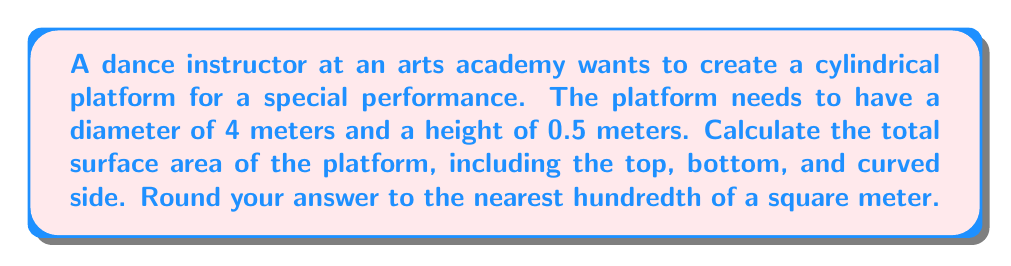Help me with this question. To solve this problem, we need to calculate the surface area of a cylinder. The surface area of a cylinder consists of three parts: the top circular face, the bottom circular face, and the curved lateral surface.

Let's break it down step by step:

1. Calculate the radius of the circular base:
   Given diameter = 4 meters
   $r = \frac{diameter}{2} = \frac{4}{2} = 2$ meters

2. Calculate the area of one circular face (top or bottom):
   $A_{circle} = \pi r^2 = \pi (2)^2 = 4\pi$ square meters

3. Calculate the area of both circular faces:
   $A_{circles} = 2 \times 4\pi = 8\pi$ square meters

4. Calculate the lateral surface area (curved side):
   Lateral surface area = circumference of base × height
   $A_{lateral} = 2\pi r \times h = 2\pi (2) \times 0.5 = 2\pi$ square meters

5. Calculate the total surface area:
   $A_{total} = A_{circles} + A_{lateral} = 8\pi + 2\pi = 10\pi$ square meters

6. Convert to numerical value and round to the nearest hundredth:
   $A_{total} = 10\pi \approx 31.42$ square meters

[asy]
import geometry;

size(200);
real r = 2;
real h = 0.5;

path base = circle((0,0),r);
path top = circle((0,h),r);

draw(base);
draw(top);
draw((r,0)--(r,h));
draw((-r,0)--(-r,h));

label("4 m", (0,-r-0.2), S);
label("0.5 m", (r+0.2,h/2), E);

[/asy]
Answer: The total surface area of the cylindrical dance platform is approximately $31.42$ square meters. 